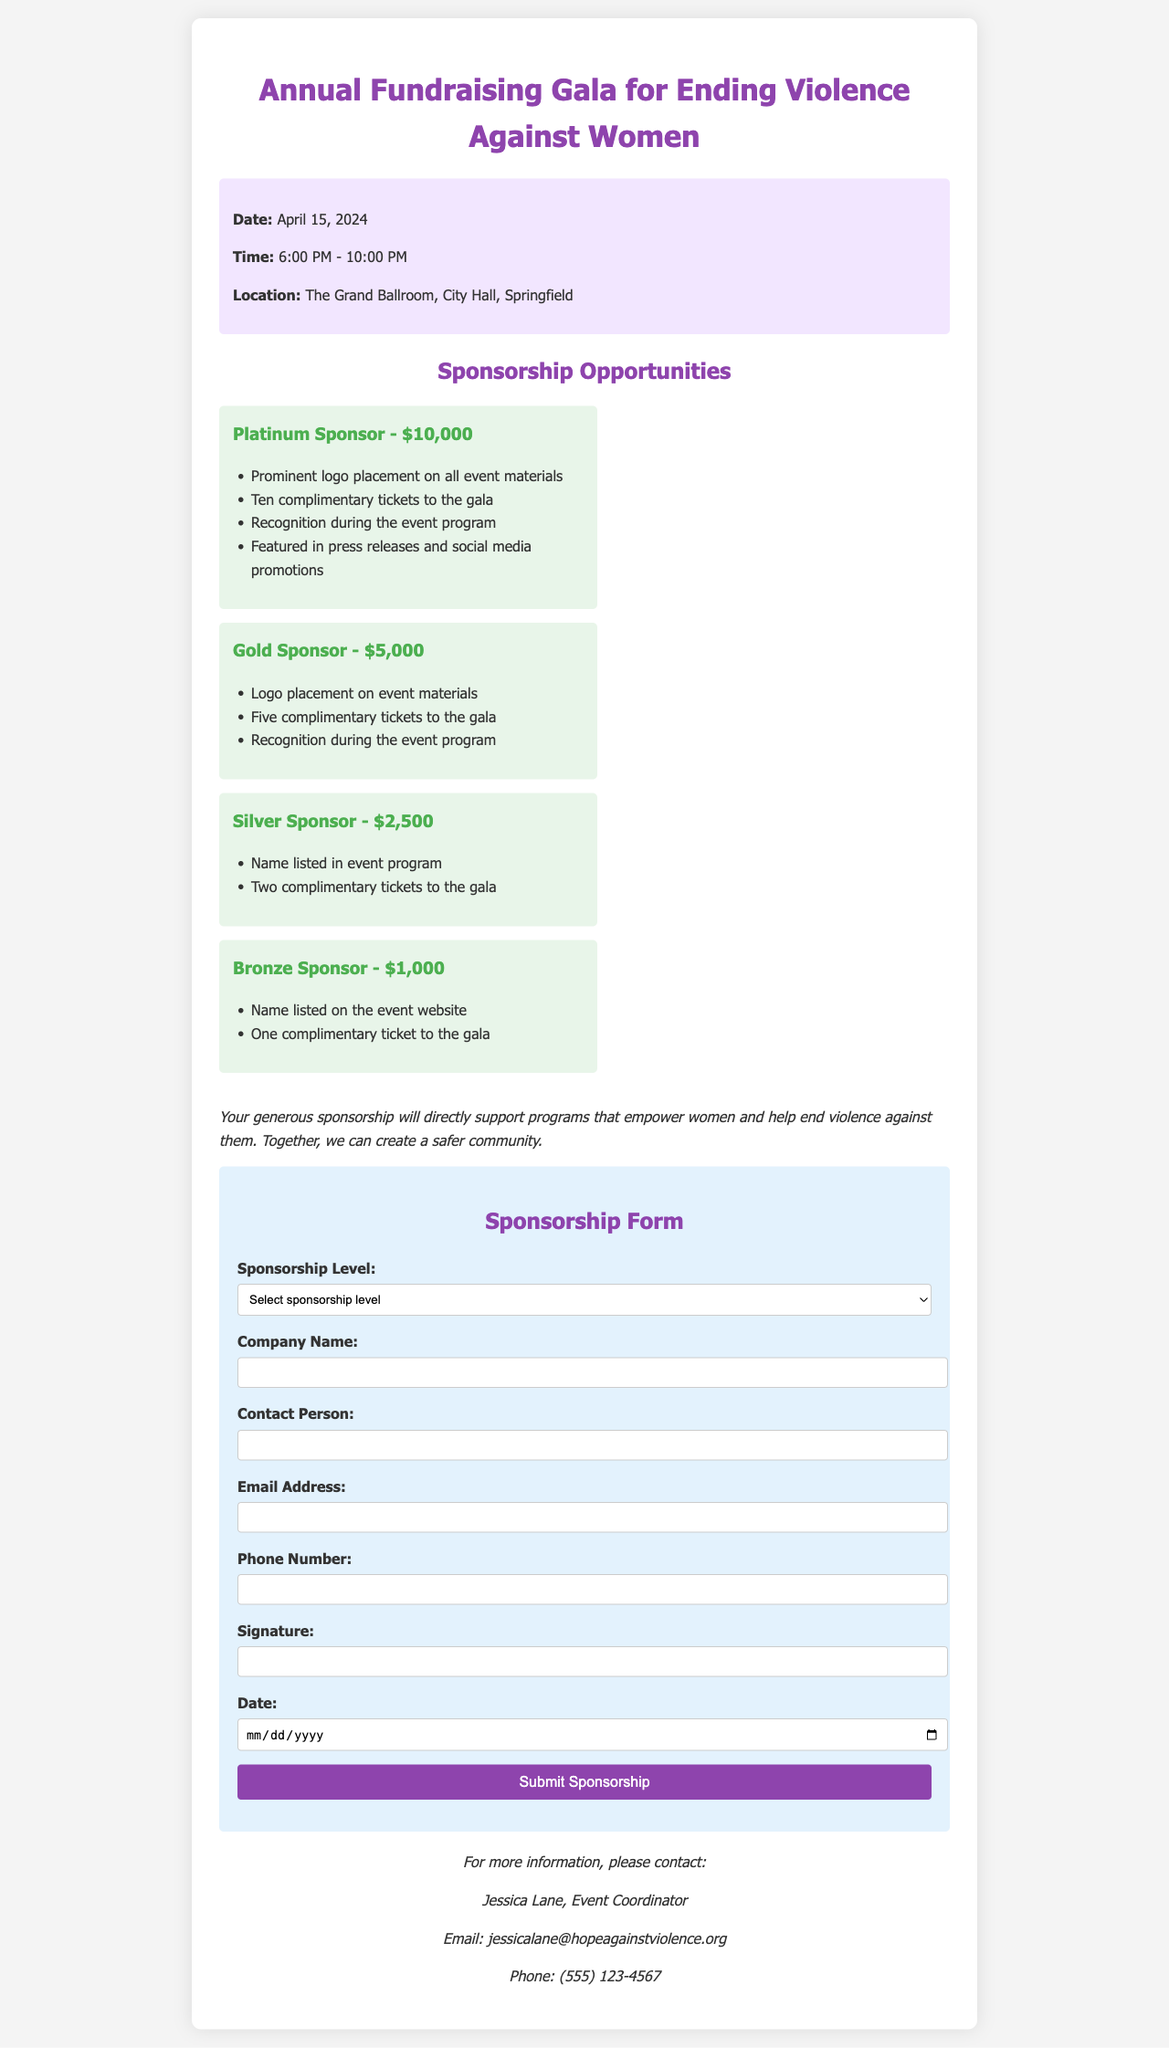What is the date of the event? The date of the event is mentioned in the document's event information section.
Answer: April 15, 2024 What is the location of the gala? The location is specified in the event information section of the document.
Answer: The Grand Ballroom, City Hall, Springfield What is the amount for a Gold Sponsor? The Gold Sponsor amount is outlined in the sponsorship opportunities section.
Answer: $5,000 How many complimentary tickets does a Platinum Sponsor receive? This information is included in the benefits listed under the Platinum Sponsor level.
Answer: Ten Who is the contact person for more information? The contact person is specified at the end of the document under contact information.
Answer: Jessica Lane How many sponsorship levels are listed? The number of sponsorship levels can be counted in the sponsorship opportunities section.
Answer: Four What kind of recognition does a Silver Sponsor receive? Recognition details for a Silver Sponsor are provided in the benefits list.
Answer: Name listed in event program What is the purpose of the sponsorship mentioned in the document? The purpose is described in a statement that emphasizes support for empowerment and ending violence.
Answer: Support programs that empower women and help end violence against them 